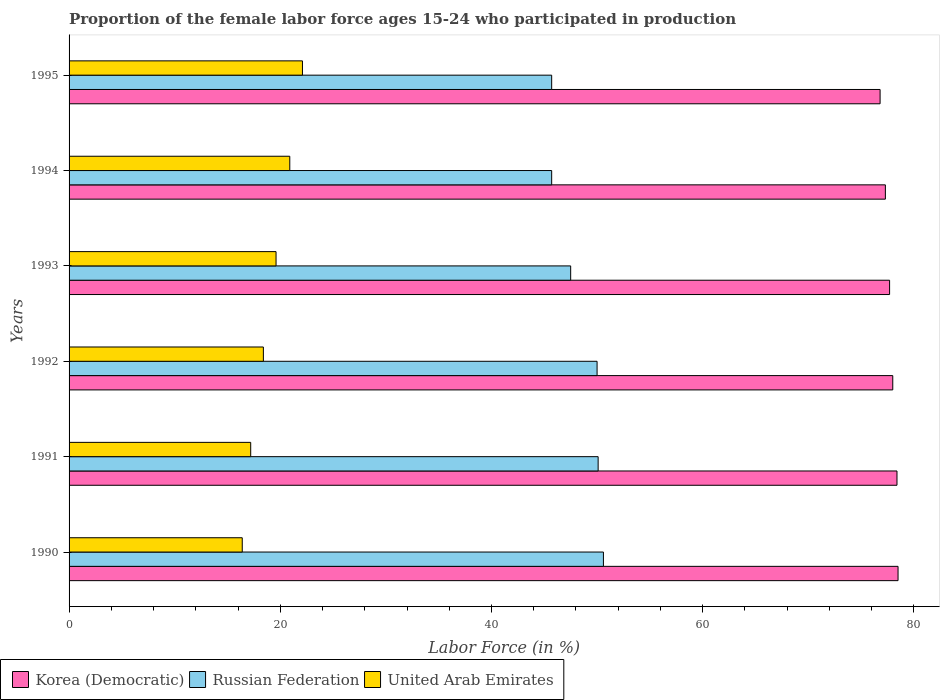How many groups of bars are there?
Offer a terse response. 6. Are the number of bars per tick equal to the number of legend labels?
Keep it short and to the point. Yes. Are the number of bars on each tick of the Y-axis equal?
Your answer should be compact. Yes. How many bars are there on the 5th tick from the bottom?
Make the answer very short. 3. What is the label of the 3rd group of bars from the top?
Give a very brief answer. 1993. In how many cases, is the number of bars for a given year not equal to the number of legend labels?
Keep it short and to the point. 0. What is the proportion of the female labor force who participated in production in Korea (Democratic) in 1991?
Provide a short and direct response. 78.4. Across all years, what is the maximum proportion of the female labor force who participated in production in Korea (Democratic)?
Offer a very short reply. 78.5. Across all years, what is the minimum proportion of the female labor force who participated in production in Korea (Democratic)?
Provide a succinct answer. 76.8. In which year was the proportion of the female labor force who participated in production in Korea (Democratic) minimum?
Provide a succinct answer. 1995. What is the total proportion of the female labor force who participated in production in Russian Federation in the graph?
Offer a very short reply. 289.6. What is the difference between the proportion of the female labor force who participated in production in Russian Federation in 1993 and that in 1994?
Offer a very short reply. 1.8. What is the difference between the proportion of the female labor force who participated in production in United Arab Emirates in 1993 and the proportion of the female labor force who participated in production in Russian Federation in 1994?
Give a very brief answer. -26.1. What is the average proportion of the female labor force who participated in production in Russian Federation per year?
Ensure brevity in your answer.  48.27. In the year 1995, what is the difference between the proportion of the female labor force who participated in production in Korea (Democratic) and proportion of the female labor force who participated in production in Russian Federation?
Your answer should be very brief. 31.1. What is the ratio of the proportion of the female labor force who participated in production in Korea (Democratic) in 1992 to that in 1994?
Your answer should be very brief. 1.01. What is the difference between the highest and the second highest proportion of the female labor force who participated in production in United Arab Emirates?
Your answer should be compact. 1.2. What is the difference between the highest and the lowest proportion of the female labor force who participated in production in Russian Federation?
Provide a short and direct response. 4.9. Is the sum of the proportion of the female labor force who participated in production in Russian Federation in 1991 and 1992 greater than the maximum proportion of the female labor force who participated in production in United Arab Emirates across all years?
Make the answer very short. Yes. What does the 3rd bar from the top in 1994 represents?
Provide a succinct answer. Korea (Democratic). What does the 3rd bar from the bottom in 1993 represents?
Your answer should be very brief. United Arab Emirates. How many bars are there?
Offer a terse response. 18. Are all the bars in the graph horizontal?
Offer a terse response. Yes. Does the graph contain any zero values?
Provide a short and direct response. No. Where does the legend appear in the graph?
Offer a terse response. Bottom left. How many legend labels are there?
Ensure brevity in your answer.  3. What is the title of the graph?
Your answer should be compact. Proportion of the female labor force ages 15-24 who participated in production. What is the label or title of the Y-axis?
Provide a short and direct response. Years. What is the Labor Force (in %) of Korea (Democratic) in 1990?
Your response must be concise. 78.5. What is the Labor Force (in %) in Russian Federation in 1990?
Provide a succinct answer. 50.6. What is the Labor Force (in %) of United Arab Emirates in 1990?
Provide a short and direct response. 16.4. What is the Labor Force (in %) in Korea (Democratic) in 1991?
Offer a terse response. 78.4. What is the Labor Force (in %) in Russian Federation in 1991?
Offer a terse response. 50.1. What is the Labor Force (in %) in United Arab Emirates in 1991?
Provide a short and direct response. 17.2. What is the Labor Force (in %) of United Arab Emirates in 1992?
Provide a short and direct response. 18.4. What is the Labor Force (in %) of Korea (Democratic) in 1993?
Offer a terse response. 77.7. What is the Labor Force (in %) of Russian Federation in 1993?
Your answer should be very brief. 47.5. What is the Labor Force (in %) in United Arab Emirates in 1993?
Ensure brevity in your answer.  19.6. What is the Labor Force (in %) in Korea (Democratic) in 1994?
Give a very brief answer. 77.3. What is the Labor Force (in %) in Russian Federation in 1994?
Provide a short and direct response. 45.7. What is the Labor Force (in %) in United Arab Emirates in 1994?
Provide a succinct answer. 20.9. What is the Labor Force (in %) in Korea (Democratic) in 1995?
Keep it short and to the point. 76.8. What is the Labor Force (in %) in Russian Federation in 1995?
Ensure brevity in your answer.  45.7. What is the Labor Force (in %) in United Arab Emirates in 1995?
Provide a succinct answer. 22.1. Across all years, what is the maximum Labor Force (in %) in Korea (Democratic)?
Offer a terse response. 78.5. Across all years, what is the maximum Labor Force (in %) in Russian Federation?
Make the answer very short. 50.6. Across all years, what is the maximum Labor Force (in %) of United Arab Emirates?
Your response must be concise. 22.1. Across all years, what is the minimum Labor Force (in %) in Korea (Democratic)?
Offer a very short reply. 76.8. Across all years, what is the minimum Labor Force (in %) of Russian Federation?
Give a very brief answer. 45.7. Across all years, what is the minimum Labor Force (in %) in United Arab Emirates?
Your answer should be compact. 16.4. What is the total Labor Force (in %) in Korea (Democratic) in the graph?
Your response must be concise. 466.7. What is the total Labor Force (in %) in Russian Federation in the graph?
Your response must be concise. 289.6. What is the total Labor Force (in %) in United Arab Emirates in the graph?
Offer a terse response. 114.6. What is the difference between the Labor Force (in %) in Korea (Democratic) in 1990 and that in 1992?
Offer a terse response. 0.5. What is the difference between the Labor Force (in %) in Russian Federation in 1990 and that in 1993?
Make the answer very short. 3.1. What is the difference between the Labor Force (in %) of United Arab Emirates in 1990 and that in 1993?
Ensure brevity in your answer.  -3.2. What is the difference between the Labor Force (in %) in Korea (Democratic) in 1990 and that in 1994?
Your response must be concise. 1.2. What is the difference between the Labor Force (in %) in Russian Federation in 1990 and that in 1994?
Offer a very short reply. 4.9. What is the difference between the Labor Force (in %) in Korea (Democratic) in 1990 and that in 1995?
Keep it short and to the point. 1.7. What is the difference between the Labor Force (in %) of Russian Federation in 1990 and that in 1995?
Your response must be concise. 4.9. What is the difference between the Labor Force (in %) of United Arab Emirates in 1991 and that in 1992?
Offer a very short reply. -1.2. What is the difference between the Labor Force (in %) of Russian Federation in 1991 and that in 1993?
Make the answer very short. 2.6. What is the difference between the Labor Force (in %) of Korea (Democratic) in 1991 and that in 1994?
Provide a short and direct response. 1.1. What is the difference between the Labor Force (in %) in United Arab Emirates in 1991 and that in 1994?
Your response must be concise. -3.7. What is the difference between the Labor Force (in %) in Korea (Democratic) in 1991 and that in 1995?
Provide a succinct answer. 1.6. What is the difference between the Labor Force (in %) of United Arab Emirates in 1991 and that in 1995?
Ensure brevity in your answer.  -4.9. What is the difference between the Labor Force (in %) in Korea (Democratic) in 1992 and that in 1993?
Provide a short and direct response. 0.3. What is the difference between the Labor Force (in %) of Russian Federation in 1992 and that in 1993?
Give a very brief answer. 2.5. What is the difference between the Labor Force (in %) in Korea (Democratic) in 1992 and that in 1994?
Offer a very short reply. 0.7. What is the difference between the Labor Force (in %) in Russian Federation in 1992 and that in 1994?
Keep it short and to the point. 4.3. What is the difference between the Labor Force (in %) of Korea (Democratic) in 1992 and that in 1995?
Provide a short and direct response. 1.2. What is the difference between the Labor Force (in %) of Korea (Democratic) in 1993 and that in 1994?
Provide a short and direct response. 0.4. What is the difference between the Labor Force (in %) in Russian Federation in 1993 and that in 1994?
Your response must be concise. 1.8. What is the difference between the Labor Force (in %) of United Arab Emirates in 1993 and that in 1994?
Offer a terse response. -1.3. What is the difference between the Labor Force (in %) of Korea (Democratic) in 1993 and that in 1995?
Give a very brief answer. 0.9. What is the difference between the Labor Force (in %) in Russian Federation in 1993 and that in 1995?
Offer a very short reply. 1.8. What is the difference between the Labor Force (in %) in Korea (Democratic) in 1994 and that in 1995?
Offer a terse response. 0.5. What is the difference between the Labor Force (in %) in Russian Federation in 1994 and that in 1995?
Offer a very short reply. 0. What is the difference between the Labor Force (in %) of Korea (Democratic) in 1990 and the Labor Force (in %) of Russian Federation in 1991?
Make the answer very short. 28.4. What is the difference between the Labor Force (in %) of Korea (Democratic) in 1990 and the Labor Force (in %) of United Arab Emirates in 1991?
Keep it short and to the point. 61.3. What is the difference between the Labor Force (in %) of Russian Federation in 1990 and the Labor Force (in %) of United Arab Emirates in 1991?
Give a very brief answer. 33.4. What is the difference between the Labor Force (in %) in Korea (Democratic) in 1990 and the Labor Force (in %) in United Arab Emirates in 1992?
Provide a succinct answer. 60.1. What is the difference between the Labor Force (in %) in Russian Federation in 1990 and the Labor Force (in %) in United Arab Emirates in 1992?
Ensure brevity in your answer.  32.2. What is the difference between the Labor Force (in %) in Korea (Democratic) in 1990 and the Labor Force (in %) in Russian Federation in 1993?
Provide a short and direct response. 31. What is the difference between the Labor Force (in %) in Korea (Democratic) in 1990 and the Labor Force (in %) in United Arab Emirates in 1993?
Provide a short and direct response. 58.9. What is the difference between the Labor Force (in %) of Korea (Democratic) in 1990 and the Labor Force (in %) of Russian Federation in 1994?
Your response must be concise. 32.8. What is the difference between the Labor Force (in %) of Korea (Democratic) in 1990 and the Labor Force (in %) of United Arab Emirates in 1994?
Your response must be concise. 57.6. What is the difference between the Labor Force (in %) in Russian Federation in 1990 and the Labor Force (in %) in United Arab Emirates in 1994?
Ensure brevity in your answer.  29.7. What is the difference between the Labor Force (in %) in Korea (Democratic) in 1990 and the Labor Force (in %) in Russian Federation in 1995?
Ensure brevity in your answer.  32.8. What is the difference between the Labor Force (in %) of Korea (Democratic) in 1990 and the Labor Force (in %) of United Arab Emirates in 1995?
Provide a short and direct response. 56.4. What is the difference between the Labor Force (in %) in Russian Federation in 1990 and the Labor Force (in %) in United Arab Emirates in 1995?
Offer a terse response. 28.5. What is the difference between the Labor Force (in %) in Korea (Democratic) in 1991 and the Labor Force (in %) in Russian Federation in 1992?
Make the answer very short. 28.4. What is the difference between the Labor Force (in %) of Russian Federation in 1991 and the Labor Force (in %) of United Arab Emirates in 1992?
Keep it short and to the point. 31.7. What is the difference between the Labor Force (in %) in Korea (Democratic) in 1991 and the Labor Force (in %) in Russian Federation in 1993?
Ensure brevity in your answer.  30.9. What is the difference between the Labor Force (in %) in Korea (Democratic) in 1991 and the Labor Force (in %) in United Arab Emirates in 1993?
Your response must be concise. 58.8. What is the difference between the Labor Force (in %) of Russian Federation in 1991 and the Labor Force (in %) of United Arab Emirates in 1993?
Your response must be concise. 30.5. What is the difference between the Labor Force (in %) of Korea (Democratic) in 1991 and the Labor Force (in %) of Russian Federation in 1994?
Keep it short and to the point. 32.7. What is the difference between the Labor Force (in %) of Korea (Democratic) in 1991 and the Labor Force (in %) of United Arab Emirates in 1994?
Make the answer very short. 57.5. What is the difference between the Labor Force (in %) of Russian Federation in 1991 and the Labor Force (in %) of United Arab Emirates in 1994?
Offer a very short reply. 29.2. What is the difference between the Labor Force (in %) of Korea (Democratic) in 1991 and the Labor Force (in %) of Russian Federation in 1995?
Offer a very short reply. 32.7. What is the difference between the Labor Force (in %) in Korea (Democratic) in 1991 and the Labor Force (in %) in United Arab Emirates in 1995?
Ensure brevity in your answer.  56.3. What is the difference between the Labor Force (in %) of Korea (Democratic) in 1992 and the Labor Force (in %) of Russian Federation in 1993?
Give a very brief answer. 30.5. What is the difference between the Labor Force (in %) of Korea (Democratic) in 1992 and the Labor Force (in %) of United Arab Emirates in 1993?
Offer a terse response. 58.4. What is the difference between the Labor Force (in %) in Russian Federation in 1992 and the Labor Force (in %) in United Arab Emirates in 1993?
Offer a very short reply. 30.4. What is the difference between the Labor Force (in %) of Korea (Democratic) in 1992 and the Labor Force (in %) of Russian Federation in 1994?
Ensure brevity in your answer.  32.3. What is the difference between the Labor Force (in %) of Korea (Democratic) in 1992 and the Labor Force (in %) of United Arab Emirates in 1994?
Offer a very short reply. 57.1. What is the difference between the Labor Force (in %) of Russian Federation in 1992 and the Labor Force (in %) of United Arab Emirates in 1994?
Offer a terse response. 29.1. What is the difference between the Labor Force (in %) in Korea (Democratic) in 1992 and the Labor Force (in %) in Russian Federation in 1995?
Keep it short and to the point. 32.3. What is the difference between the Labor Force (in %) of Korea (Democratic) in 1992 and the Labor Force (in %) of United Arab Emirates in 1995?
Your response must be concise. 55.9. What is the difference between the Labor Force (in %) in Russian Federation in 1992 and the Labor Force (in %) in United Arab Emirates in 1995?
Provide a short and direct response. 27.9. What is the difference between the Labor Force (in %) in Korea (Democratic) in 1993 and the Labor Force (in %) in Russian Federation in 1994?
Offer a very short reply. 32. What is the difference between the Labor Force (in %) of Korea (Democratic) in 1993 and the Labor Force (in %) of United Arab Emirates in 1994?
Your answer should be very brief. 56.8. What is the difference between the Labor Force (in %) in Russian Federation in 1993 and the Labor Force (in %) in United Arab Emirates in 1994?
Your answer should be compact. 26.6. What is the difference between the Labor Force (in %) in Korea (Democratic) in 1993 and the Labor Force (in %) in United Arab Emirates in 1995?
Make the answer very short. 55.6. What is the difference between the Labor Force (in %) in Russian Federation in 1993 and the Labor Force (in %) in United Arab Emirates in 1995?
Give a very brief answer. 25.4. What is the difference between the Labor Force (in %) in Korea (Democratic) in 1994 and the Labor Force (in %) in Russian Federation in 1995?
Make the answer very short. 31.6. What is the difference between the Labor Force (in %) in Korea (Democratic) in 1994 and the Labor Force (in %) in United Arab Emirates in 1995?
Your answer should be very brief. 55.2. What is the difference between the Labor Force (in %) in Russian Federation in 1994 and the Labor Force (in %) in United Arab Emirates in 1995?
Offer a very short reply. 23.6. What is the average Labor Force (in %) of Korea (Democratic) per year?
Your answer should be compact. 77.78. What is the average Labor Force (in %) of Russian Federation per year?
Offer a terse response. 48.27. What is the average Labor Force (in %) of United Arab Emirates per year?
Keep it short and to the point. 19.1. In the year 1990, what is the difference between the Labor Force (in %) in Korea (Democratic) and Labor Force (in %) in Russian Federation?
Ensure brevity in your answer.  27.9. In the year 1990, what is the difference between the Labor Force (in %) of Korea (Democratic) and Labor Force (in %) of United Arab Emirates?
Provide a short and direct response. 62.1. In the year 1990, what is the difference between the Labor Force (in %) of Russian Federation and Labor Force (in %) of United Arab Emirates?
Provide a short and direct response. 34.2. In the year 1991, what is the difference between the Labor Force (in %) of Korea (Democratic) and Labor Force (in %) of Russian Federation?
Provide a short and direct response. 28.3. In the year 1991, what is the difference between the Labor Force (in %) of Korea (Democratic) and Labor Force (in %) of United Arab Emirates?
Give a very brief answer. 61.2. In the year 1991, what is the difference between the Labor Force (in %) in Russian Federation and Labor Force (in %) in United Arab Emirates?
Your answer should be very brief. 32.9. In the year 1992, what is the difference between the Labor Force (in %) in Korea (Democratic) and Labor Force (in %) in Russian Federation?
Keep it short and to the point. 28. In the year 1992, what is the difference between the Labor Force (in %) of Korea (Democratic) and Labor Force (in %) of United Arab Emirates?
Keep it short and to the point. 59.6. In the year 1992, what is the difference between the Labor Force (in %) in Russian Federation and Labor Force (in %) in United Arab Emirates?
Provide a succinct answer. 31.6. In the year 1993, what is the difference between the Labor Force (in %) of Korea (Democratic) and Labor Force (in %) of Russian Federation?
Make the answer very short. 30.2. In the year 1993, what is the difference between the Labor Force (in %) in Korea (Democratic) and Labor Force (in %) in United Arab Emirates?
Offer a very short reply. 58.1. In the year 1993, what is the difference between the Labor Force (in %) of Russian Federation and Labor Force (in %) of United Arab Emirates?
Your response must be concise. 27.9. In the year 1994, what is the difference between the Labor Force (in %) of Korea (Democratic) and Labor Force (in %) of Russian Federation?
Provide a short and direct response. 31.6. In the year 1994, what is the difference between the Labor Force (in %) in Korea (Democratic) and Labor Force (in %) in United Arab Emirates?
Offer a very short reply. 56.4. In the year 1994, what is the difference between the Labor Force (in %) in Russian Federation and Labor Force (in %) in United Arab Emirates?
Make the answer very short. 24.8. In the year 1995, what is the difference between the Labor Force (in %) of Korea (Democratic) and Labor Force (in %) of Russian Federation?
Keep it short and to the point. 31.1. In the year 1995, what is the difference between the Labor Force (in %) of Korea (Democratic) and Labor Force (in %) of United Arab Emirates?
Ensure brevity in your answer.  54.7. In the year 1995, what is the difference between the Labor Force (in %) in Russian Federation and Labor Force (in %) in United Arab Emirates?
Offer a very short reply. 23.6. What is the ratio of the Labor Force (in %) in Korea (Democratic) in 1990 to that in 1991?
Offer a terse response. 1. What is the ratio of the Labor Force (in %) in United Arab Emirates in 1990 to that in 1991?
Keep it short and to the point. 0.95. What is the ratio of the Labor Force (in %) in Korea (Democratic) in 1990 to that in 1992?
Give a very brief answer. 1.01. What is the ratio of the Labor Force (in %) in United Arab Emirates in 1990 to that in 1992?
Ensure brevity in your answer.  0.89. What is the ratio of the Labor Force (in %) of Korea (Democratic) in 1990 to that in 1993?
Offer a terse response. 1.01. What is the ratio of the Labor Force (in %) of Russian Federation in 1990 to that in 1993?
Give a very brief answer. 1.07. What is the ratio of the Labor Force (in %) of United Arab Emirates in 1990 to that in 1993?
Offer a terse response. 0.84. What is the ratio of the Labor Force (in %) of Korea (Democratic) in 1990 to that in 1994?
Provide a short and direct response. 1.02. What is the ratio of the Labor Force (in %) in Russian Federation in 1990 to that in 1994?
Ensure brevity in your answer.  1.11. What is the ratio of the Labor Force (in %) of United Arab Emirates in 1990 to that in 1994?
Offer a very short reply. 0.78. What is the ratio of the Labor Force (in %) of Korea (Democratic) in 1990 to that in 1995?
Provide a short and direct response. 1.02. What is the ratio of the Labor Force (in %) of Russian Federation in 1990 to that in 1995?
Make the answer very short. 1.11. What is the ratio of the Labor Force (in %) of United Arab Emirates in 1990 to that in 1995?
Offer a terse response. 0.74. What is the ratio of the Labor Force (in %) in Korea (Democratic) in 1991 to that in 1992?
Keep it short and to the point. 1.01. What is the ratio of the Labor Force (in %) of Russian Federation in 1991 to that in 1992?
Your answer should be very brief. 1. What is the ratio of the Labor Force (in %) of United Arab Emirates in 1991 to that in 1992?
Keep it short and to the point. 0.93. What is the ratio of the Labor Force (in %) of Korea (Democratic) in 1991 to that in 1993?
Offer a very short reply. 1.01. What is the ratio of the Labor Force (in %) in Russian Federation in 1991 to that in 1993?
Give a very brief answer. 1.05. What is the ratio of the Labor Force (in %) of United Arab Emirates in 1991 to that in 1993?
Your answer should be very brief. 0.88. What is the ratio of the Labor Force (in %) of Korea (Democratic) in 1991 to that in 1994?
Give a very brief answer. 1.01. What is the ratio of the Labor Force (in %) in Russian Federation in 1991 to that in 1994?
Ensure brevity in your answer.  1.1. What is the ratio of the Labor Force (in %) in United Arab Emirates in 1991 to that in 1994?
Provide a succinct answer. 0.82. What is the ratio of the Labor Force (in %) in Korea (Democratic) in 1991 to that in 1995?
Ensure brevity in your answer.  1.02. What is the ratio of the Labor Force (in %) of Russian Federation in 1991 to that in 1995?
Make the answer very short. 1.1. What is the ratio of the Labor Force (in %) of United Arab Emirates in 1991 to that in 1995?
Your answer should be compact. 0.78. What is the ratio of the Labor Force (in %) in Korea (Democratic) in 1992 to that in 1993?
Give a very brief answer. 1. What is the ratio of the Labor Force (in %) in Russian Federation in 1992 to that in 1993?
Give a very brief answer. 1.05. What is the ratio of the Labor Force (in %) in United Arab Emirates in 1992 to that in 1993?
Make the answer very short. 0.94. What is the ratio of the Labor Force (in %) in Korea (Democratic) in 1992 to that in 1994?
Ensure brevity in your answer.  1.01. What is the ratio of the Labor Force (in %) in Russian Federation in 1992 to that in 1994?
Provide a succinct answer. 1.09. What is the ratio of the Labor Force (in %) in United Arab Emirates in 1992 to that in 1994?
Provide a short and direct response. 0.88. What is the ratio of the Labor Force (in %) in Korea (Democratic) in 1992 to that in 1995?
Give a very brief answer. 1.02. What is the ratio of the Labor Force (in %) of Russian Federation in 1992 to that in 1995?
Offer a terse response. 1.09. What is the ratio of the Labor Force (in %) in United Arab Emirates in 1992 to that in 1995?
Ensure brevity in your answer.  0.83. What is the ratio of the Labor Force (in %) in Korea (Democratic) in 1993 to that in 1994?
Give a very brief answer. 1.01. What is the ratio of the Labor Force (in %) in Russian Federation in 1993 to that in 1994?
Offer a very short reply. 1.04. What is the ratio of the Labor Force (in %) in United Arab Emirates in 1993 to that in 1994?
Give a very brief answer. 0.94. What is the ratio of the Labor Force (in %) in Korea (Democratic) in 1993 to that in 1995?
Provide a short and direct response. 1.01. What is the ratio of the Labor Force (in %) of Russian Federation in 1993 to that in 1995?
Your response must be concise. 1.04. What is the ratio of the Labor Force (in %) in United Arab Emirates in 1993 to that in 1995?
Your response must be concise. 0.89. What is the ratio of the Labor Force (in %) in Korea (Democratic) in 1994 to that in 1995?
Offer a terse response. 1.01. What is the ratio of the Labor Force (in %) of United Arab Emirates in 1994 to that in 1995?
Your answer should be compact. 0.95. What is the difference between the highest and the second highest Labor Force (in %) in Korea (Democratic)?
Provide a short and direct response. 0.1. What is the difference between the highest and the second highest Labor Force (in %) of Russian Federation?
Provide a succinct answer. 0.5. What is the difference between the highest and the lowest Labor Force (in %) in Russian Federation?
Give a very brief answer. 4.9. 